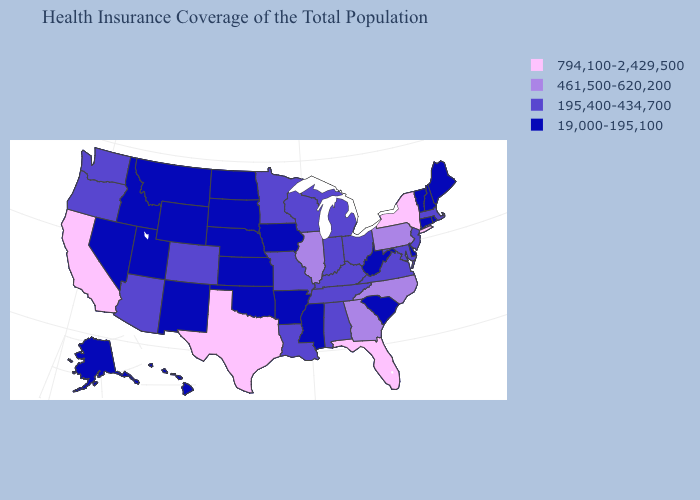What is the value of Wyoming?
Be succinct. 19,000-195,100. Is the legend a continuous bar?
Short answer required. No. Does Wisconsin have a lower value than Arizona?
Be succinct. No. Among the states that border Maryland , which have the highest value?
Concise answer only. Pennsylvania. Name the states that have a value in the range 195,400-434,700?
Short answer required. Alabama, Arizona, Colorado, Indiana, Kentucky, Louisiana, Maryland, Massachusetts, Michigan, Minnesota, Missouri, New Jersey, Ohio, Oregon, Tennessee, Virginia, Washington, Wisconsin. Does New Hampshire have the highest value in the Northeast?
Answer briefly. No. Among the states that border Arizona , which have the highest value?
Answer briefly. California. Does Virginia have the lowest value in the USA?
Concise answer only. No. Does Michigan have the lowest value in the USA?
Write a very short answer. No. What is the value of South Carolina?
Quick response, please. 19,000-195,100. What is the value of Mississippi?
Be succinct. 19,000-195,100. How many symbols are there in the legend?
Write a very short answer. 4. Which states have the lowest value in the Northeast?
Write a very short answer. Connecticut, Maine, New Hampshire, Rhode Island, Vermont. What is the lowest value in states that border Pennsylvania?
Write a very short answer. 19,000-195,100. What is the value of Virginia?
Be succinct. 195,400-434,700. 